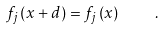<formula> <loc_0><loc_0><loc_500><loc_500>f _ { j } \left ( x + d \right ) = f _ { j } \left ( x \right ) \quad .</formula> 